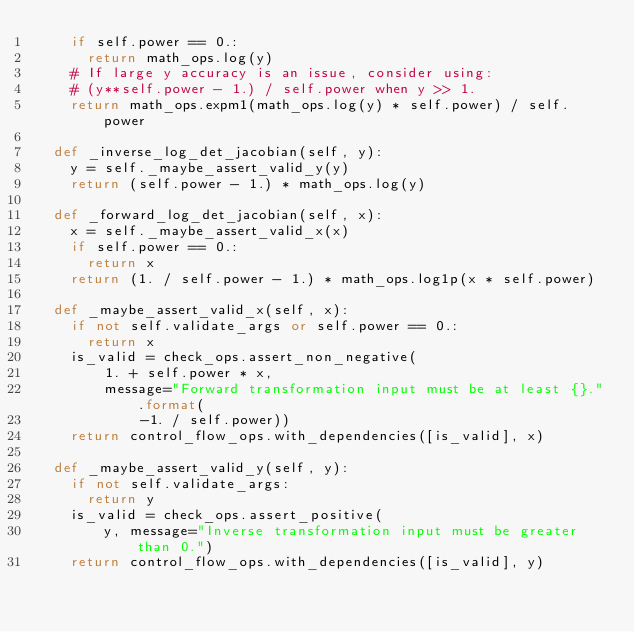<code> <loc_0><loc_0><loc_500><loc_500><_Python_>    if self.power == 0.:
      return math_ops.log(y)
    # If large y accuracy is an issue, consider using:
    # (y**self.power - 1.) / self.power when y >> 1.
    return math_ops.expm1(math_ops.log(y) * self.power) / self.power

  def _inverse_log_det_jacobian(self, y):
    y = self._maybe_assert_valid_y(y)
    return (self.power - 1.) * math_ops.log(y)

  def _forward_log_det_jacobian(self, x):
    x = self._maybe_assert_valid_x(x)
    if self.power == 0.:
      return x
    return (1. / self.power - 1.) * math_ops.log1p(x * self.power)

  def _maybe_assert_valid_x(self, x):
    if not self.validate_args or self.power == 0.:
      return x
    is_valid = check_ops.assert_non_negative(
        1. + self.power * x,
        message="Forward transformation input must be at least {}.".format(
            -1. / self.power))
    return control_flow_ops.with_dependencies([is_valid], x)

  def _maybe_assert_valid_y(self, y):
    if not self.validate_args:
      return y
    is_valid = check_ops.assert_positive(
        y, message="Inverse transformation input must be greater than 0.")
    return control_flow_ops.with_dependencies([is_valid], y)
</code> 